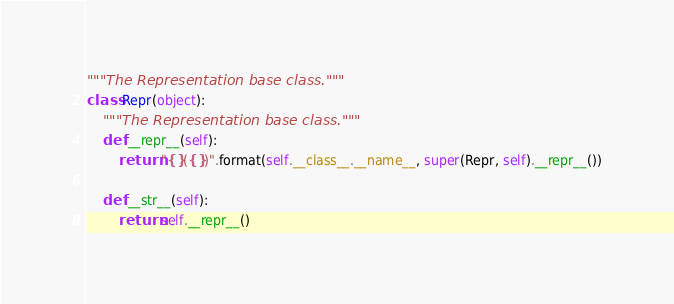Convert code to text. <code><loc_0><loc_0><loc_500><loc_500><_Python_>"""The Representation base class."""
class Repr(object):
    """The Representation base class."""
    def __repr__(self):
        return "{}({})".format(self.__class__.__name__, super(Repr, self).__repr__())

    def __str__(self):
        return self.__repr__()
</code> 